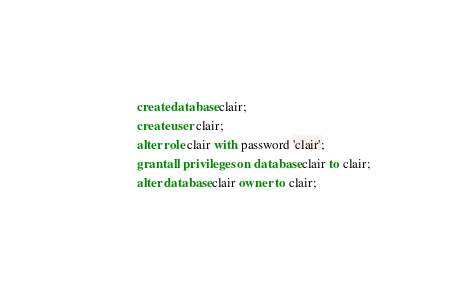Convert code to text. <code><loc_0><loc_0><loc_500><loc_500><_SQL_>create database clair;
create user clair;
alter role clair with password 'clair';
grant all privileges on database clair to clair;
alter database clair owner to clair;

</code> 